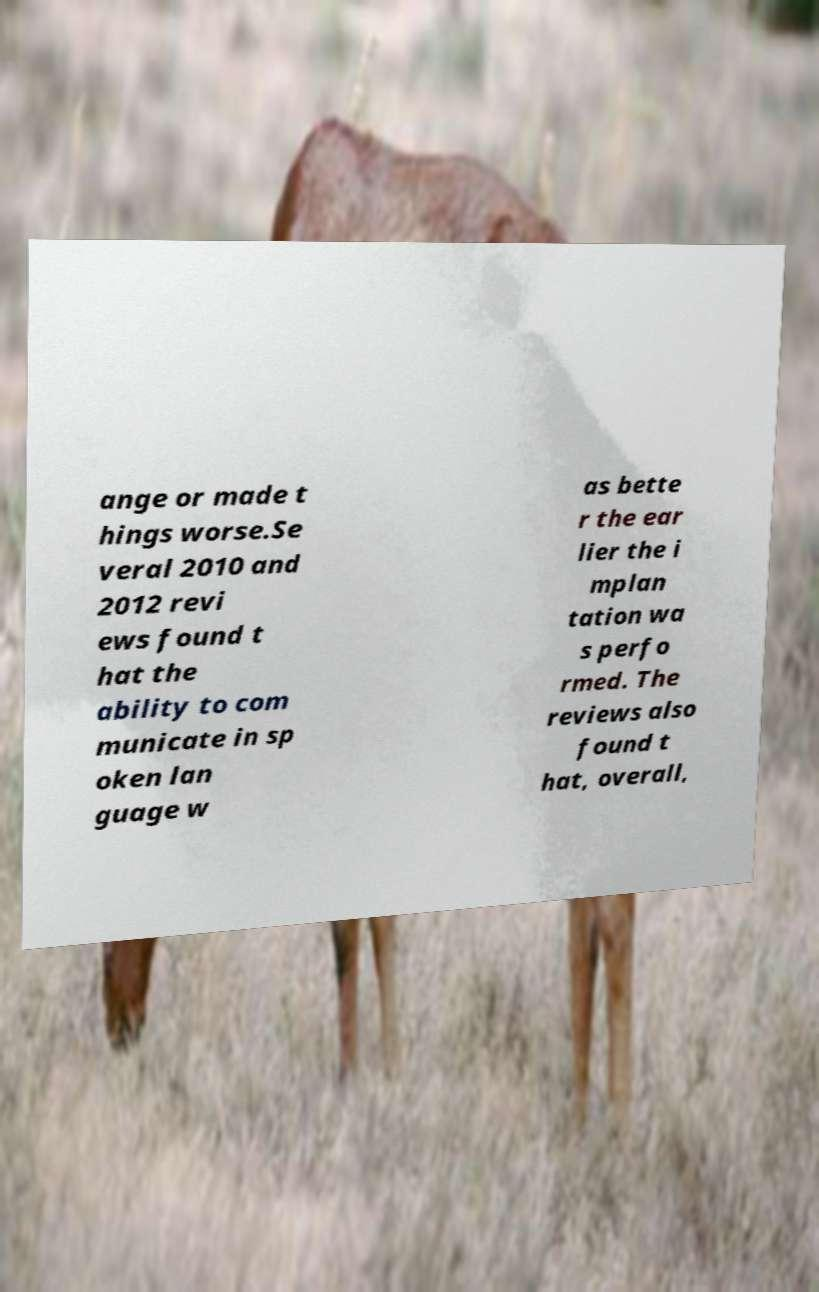Can you read and provide the text displayed in the image?This photo seems to have some interesting text. Can you extract and type it out for me? ange or made t hings worse.Se veral 2010 and 2012 revi ews found t hat the ability to com municate in sp oken lan guage w as bette r the ear lier the i mplan tation wa s perfo rmed. The reviews also found t hat, overall, 